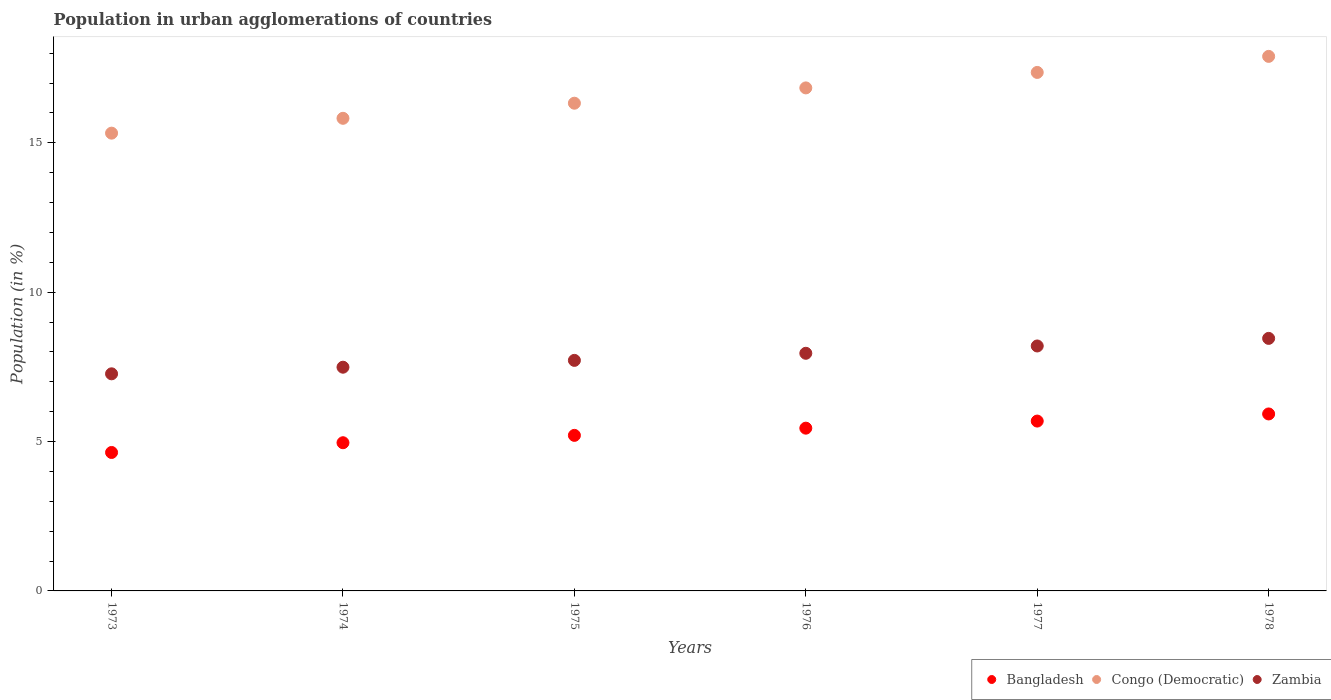How many different coloured dotlines are there?
Your response must be concise. 3. Is the number of dotlines equal to the number of legend labels?
Keep it short and to the point. Yes. What is the percentage of population in urban agglomerations in Bangladesh in 1974?
Provide a short and direct response. 4.96. Across all years, what is the maximum percentage of population in urban agglomerations in Bangladesh?
Provide a short and direct response. 5.92. Across all years, what is the minimum percentage of population in urban agglomerations in Congo (Democratic)?
Your answer should be compact. 15.32. In which year was the percentage of population in urban agglomerations in Bangladesh maximum?
Provide a short and direct response. 1978. What is the total percentage of population in urban agglomerations in Congo (Democratic) in the graph?
Keep it short and to the point. 99.55. What is the difference between the percentage of population in urban agglomerations in Zambia in 1974 and that in 1976?
Make the answer very short. -0.47. What is the difference between the percentage of population in urban agglomerations in Bangladesh in 1978 and the percentage of population in urban agglomerations in Zambia in 1977?
Ensure brevity in your answer.  -2.28. What is the average percentage of population in urban agglomerations in Congo (Democratic) per year?
Your response must be concise. 16.59. In the year 1978, what is the difference between the percentage of population in urban agglomerations in Bangladesh and percentage of population in urban agglomerations in Zambia?
Keep it short and to the point. -2.53. What is the ratio of the percentage of population in urban agglomerations in Zambia in 1975 to that in 1976?
Your answer should be compact. 0.97. Is the difference between the percentage of population in urban agglomerations in Bangladesh in 1974 and 1976 greater than the difference between the percentage of population in urban agglomerations in Zambia in 1974 and 1976?
Provide a succinct answer. No. What is the difference between the highest and the second highest percentage of population in urban agglomerations in Bangladesh?
Give a very brief answer. 0.24. What is the difference between the highest and the lowest percentage of population in urban agglomerations in Bangladesh?
Give a very brief answer. 1.29. Does the percentage of population in urban agglomerations in Bangladesh monotonically increase over the years?
Give a very brief answer. Yes. Is the percentage of population in urban agglomerations in Zambia strictly less than the percentage of population in urban agglomerations in Bangladesh over the years?
Your answer should be very brief. No. How many dotlines are there?
Offer a very short reply. 3. What is the difference between two consecutive major ticks on the Y-axis?
Give a very brief answer. 5. Are the values on the major ticks of Y-axis written in scientific E-notation?
Ensure brevity in your answer.  No. What is the title of the graph?
Make the answer very short. Population in urban agglomerations of countries. Does "China" appear as one of the legend labels in the graph?
Give a very brief answer. No. What is the label or title of the X-axis?
Provide a short and direct response. Years. What is the label or title of the Y-axis?
Offer a terse response. Population (in %). What is the Population (in %) in Bangladesh in 1973?
Your answer should be very brief. 4.63. What is the Population (in %) of Congo (Democratic) in 1973?
Offer a very short reply. 15.32. What is the Population (in %) in Zambia in 1973?
Offer a terse response. 7.27. What is the Population (in %) of Bangladesh in 1974?
Keep it short and to the point. 4.96. What is the Population (in %) in Congo (Democratic) in 1974?
Your answer should be very brief. 15.82. What is the Population (in %) in Zambia in 1974?
Offer a very short reply. 7.49. What is the Population (in %) in Bangladesh in 1975?
Your answer should be very brief. 5.21. What is the Population (in %) in Congo (Democratic) in 1975?
Your answer should be very brief. 16.33. What is the Population (in %) in Zambia in 1975?
Make the answer very short. 7.72. What is the Population (in %) in Bangladesh in 1976?
Keep it short and to the point. 5.45. What is the Population (in %) of Congo (Democratic) in 1976?
Make the answer very short. 16.84. What is the Population (in %) of Zambia in 1976?
Offer a terse response. 7.95. What is the Population (in %) in Bangladesh in 1977?
Your answer should be compact. 5.69. What is the Population (in %) of Congo (Democratic) in 1977?
Keep it short and to the point. 17.36. What is the Population (in %) of Zambia in 1977?
Your answer should be very brief. 8.2. What is the Population (in %) of Bangladesh in 1978?
Your answer should be very brief. 5.92. What is the Population (in %) of Congo (Democratic) in 1978?
Offer a very short reply. 17.89. What is the Population (in %) of Zambia in 1978?
Your answer should be compact. 8.45. Across all years, what is the maximum Population (in %) of Bangladesh?
Your answer should be compact. 5.92. Across all years, what is the maximum Population (in %) in Congo (Democratic)?
Offer a very short reply. 17.89. Across all years, what is the maximum Population (in %) in Zambia?
Offer a terse response. 8.45. Across all years, what is the minimum Population (in %) of Bangladesh?
Your response must be concise. 4.63. Across all years, what is the minimum Population (in %) in Congo (Democratic)?
Offer a terse response. 15.32. Across all years, what is the minimum Population (in %) of Zambia?
Your response must be concise. 7.27. What is the total Population (in %) in Bangladesh in the graph?
Your answer should be very brief. 31.86. What is the total Population (in %) of Congo (Democratic) in the graph?
Your response must be concise. 99.55. What is the total Population (in %) of Zambia in the graph?
Make the answer very short. 47.08. What is the difference between the Population (in %) in Bangladesh in 1973 and that in 1974?
Provide a short and direct response. -0.33. What is the difference between the Population (in %) of Congo (Democratic) in 1973 and that in 1974?
Your answer should be very brief. -0.5. What is the difference between the Population (in %) of Zambia in 1973 and that in 1974?
Provide a short and direct response. -0.22. What is the difference between the Population (in %) in Bangladesh in 1973 and that in 1975?
Your answer should be very brief. -0.57. What is the difference between the Population (in %) of Congo (Democratic) in 1973 and that in 1975?
Give a very brief answer. -1. What is the difference between the Population (in %) of Zambia in 1973 and that in 1975?
Your answer should be compact. -0.45. What is the difference between the Population (in %) of Bangladesh in 1973 and that in 1976?
Offer a terse response. -0.81. What is the difference between the Population (in %) in Congo (Democratic) in 1973 and that in 1976?
Keep it short and to the point. -1.51. What is the difference between the Population (in %) in Zambia in 1973 and that in 1976?
Your answer should be very brief. -0.69. What is the difference between the Population (in %) in Bangladesh in 1973 and that in 1977?
Provide a succinct answer. -1.05. What is the difference between the Population (in %) in Congo (Democratic) in 1973 and that in 1977?
Provide a short and direct response. -2.03. What is the difference between the Population (in %) of Zambia in 1973 and that in 1977?
Offer a very short reply. -0.93. What is the difference between the Population (in %) of Bangladesh in 1973 and that in 1978?
Your response must be concise. -1.29. What is the difference between the Population (in %) of Congo (Democratic) in 1973 and that in 1978?
Your response must be concise. -2.57. What is the difference between the Population (in %) in Zambia in 1973 and that in 1978?
Provide a succinct answer. -1.19. What is the difference between the Population (in %) in Bangladesh in 1974 and that in 1975?
Offer a terse response. -0.25. What is the difference between the Population (in %) of Congo (Democratic) in 1974 and that in 1975?
Your response must be concise. -0.51. What is the difference between the Population (in %) in Zambia in 1974 and that in 1975?
Give a very brief answer. -0.23. What is the difference between the Population (in %) of Bangladesh in 1974 and that in 1976?
Your answer should be compact. -0.49. What is the difference between the Population (in %) of Congo (Democratic) in 1974 and that in 1976?
Offer a terse response. -1.02. What is the difference between the Population (in %) in Zambia in 1974 and that in 1976?
Offer a very short reply. -0.47. What is the difference between the Population (in %) in Bangladesh in 1974 and that in 1977?
Ensure brevity in your answer.  -0.72. What is the difference between the Population (in %) of Congo (Democratic) in 1974 and that in 1977?
Ensure brevity in your answer.  -1.54. What is the difference between the Population (in %) of Zambia in 1974 and that in 1977?
Make the answer very short. -0.71. What is the difference between the Population (in %) in Bangladesh in 1974 and that in 1978?
Your answer should be compact. -0.96. What is the difference between the Population (in %) of Congo (Democratic) in 1974 and that in 1978?
Provide a succinct answer. -2.07. What is the difference between the Population (in %) of Zambia in 1974 and that in 1978?
Provide a succinct answer. -0.96. What is the difference between the Population (in %) of Bangladesh in 1975 and that in 1976?
Provide a succinct answer. -0.24. What is the difference between the Population (in %) in Congo (Democratic) in 1975 and that in 1976?
Make the answer very short. -0.51. What is the difference between the Population (in %) of Zambia in 1975 and that in 1976?
Offer a very short reply. -0.24. What is the difference between the Population (in %) of Bangladesh in 1975 and that in 1977?
Keep it short and to the point. -0.48. What is the difference between the Population (in %) of Congo (Democratic) in 1975 and that in 1977?
Your answer should be very brief. -1.03. What is the difference between the Population (in %) of Zambia in 1975 and that in 1977?
Your response must be concise. -0.48. What is the difference between the Population (in %) in Bangladesh in 1975 and that in 1978?
Your answer should be very brief. -0.72. What is the difference between the Population (in %) in Congo (Democratic) in 1975 and that in 1978?
Make the answer very short. -1.57. What is the difference between the Population (in %) in Zambia in 1975 and that in 1978?
Your answer should be very brief. -0.74. What is the difference between the Population (in %) in Bangladesh in 1976 and that in 1977?
Ensure brevity in your answer.  -0.24. What is the difference between the Population (in %) of Congo (Democratic) in 1976 and that in 1977?
Provide a short and direct response. -0.52. What is the difference between the Population (in %) in Zambia in 1976 and that in 1977?
Provide a succinct answer. -0.24. What is the difference between the Population (in %) of Bangladesh in 1976 and that in 1978?
Make the answer very short. -0.48. What is the difference between the Population (in %) of Congo (Democratic) in 1976 and that in 1978?
Provide a short and direct response. -1.06. What is the difference between the Population (in %) in Zambia in 1976 and that in 1978?
Provide a succinct answer. -0.5. What is the difference between the Population (in %) of Bangladesh in 1977 and that in 1978?
Offer a very short reply. -0.24. What is the difference between the Population (in %) of Congo (Democratic) in 1977 and that in 1978?
Your answer should be compact. -0.54. What is the difference between the Population (in %) in Zambia in 1977 and that in 1978?
Keep it short and to the point. -0.25. What is the difference between the Population (in %) in Bangladesh in 1973 and the Population (in %) in Congo (Democratic) in 1974?
Offer a very short reply. -11.19. What is the difference between the Population (in %) in Bangladesh in 1973 and the Population (in %) in Zambia in 1974?
Your response must be concise. -2.85. What is the difference between the Population (in %) of Congo (Democratic) in 1973 and the Population (in %) of Zambia in 1974?
Offer a terse response. 7.83. What is the difference between the Population (in %) of Bangladesh in 1973 and the Population (in %) of Congo (Democratic) in 1975?
Offer a very short reply. -11.69. What is the difference between the Population (in %) in Bangladesh in 1973 and the Population (in %) in Zambia in 1975?
Your response must be concise. -3.08. What is the difference between the Population (in %) of Congo (Democratic) in 1973 and the Population (in %) of Zambia in 1975?
Provide a succinct answer. 7.61. What is the difference between the Population (in %) of Bangladesh in 1973 and the Population (in %) of Congo (Democratic) in 1976?
Make the answer very short. -12.2. What is the difference between the Population (in %) in Bangladesh in 1973 and the Population (in %) in Zambia in 1976?
Offer a terse response. -3.32. What is the difference between the Population (in %) in Congo (Democratic) in 1973 and the Population (in %) in Zambia in 1976?
Your answer should be very brief. 7.37. What is the difference between the Population (in %) of Bangladesh in 1973 and the Population (in %) of Congo (Democratic) in 1977?
Provide a succinct answer. -12.72. What is the difference between the Population (in %) of Bangladesh in 1973 and the Population (in %) of Zambia in 1977?
Make the answer very short. -3.56. What is the difference between the Population (in %) of Congo (Democratic) in 1973 and the Population (in %) of Zambia in 1977?
Ensure brevity in your answer.  7.12. What is the difference between the Population (in %) in Bangladesh in 1973 and the Population (in %) in Congo (Democratic) in 1978?
Your response must be concise. -13.26. What is the difference between the Population (in %) in Bangladesh in 1973 and the Population (in %) in Zambia in 1978?
Give a very brief answer. -3.82. What is the difference between the Population (in %) of Congo (Democratic) in 1973 and the Population (in %) of Zambia in 1978?
Provide a short and direct response. 6.87. What is the difference between the Population (in %) of Bangladesh in 1974 and the Population (in %) of Congo (Democratic) in 1975?
Ensure brevity in your answer.  -11.37. What is the difference between the Population (in %) of Bangladesh in 1974 and the Population (in %) of Zambia in 1975?
Offer a terse response. -2.76. What is the difference between the Population (in %) of Congo (Democratic) in 1974 and the Population (in %) of Zambia in 1975?
Keep it short and to the point. 8.1. What is the difference between the Population (in %) in Bangladesh in 1974 and the Population (in %) in Congo (Democratic) in 1976?
Ensure brevity in your answer.  -11.88. What is the difference between the Population (in %) in Bangladesh in 1974 and the Population (in %) in Zambia in 1976?
Offer a very short reply. -2.99. What is the difference between the Population (in %) in Congo (Democratic) in 1974 and the Population (in %) in Zambia in 1976?
Keep it short and to the point. 7.87. What is the difference between the Population (in %) of Bangladesh in 1974 and the Population (in %) of Congo (Democratic) in 1977?
Offer a terse response. -12.4. What is the difference between the Population (in %) of Bangladesh in 1974 and the Population (in %) of Zambia in 1977?
Offer a terse response. -3.24. What is the difference between the Population (in %) in Congo (Democratic) in 1974 and the Population (in %) in Zambia in 1977?
Make the answer very short. 7.62. What is the difference between the Population (in %) in Bangladesh in 1974 and the Population (in %) in Congo (Democratic) in 1978?
Ensure brevity in your answer.  -12.93. What is the difference between the Population (in %) in Bangladesh in 1974 and the Population (in %) in Zambia in 1978?
Provide a short and direct response. -3.49. What is the difference between the Population (in %) of Congo (Democratic) in 1974 and the Population (in %) of Zambia in 1978?
Your response must be concise. 7.37. What is the difference between the Population (in %) in Bangladesh in 1975 and the Population (in %) in Congo (Democratic) in 1976?
Provide a short and direct response. -11.63. What is the difference between the Population (in %) in Bangladesh in 1975 and the Population (in %) in Zambia in 1976?
Keep it short and to the point. -2.75. What is the difference between the Population (in %) in Congo (Democratic) in 1975 and the Population (in %) in Zambia in 1976?
Ensure brevity in your answer.  8.37. What is the difference between the Population (in %) of Bangladesh in 1975 and the Population (in %) of Congo (Democratic) in 1977?
Keep it short and to the point. -12.15. What is the difference between the Population (in %) of Bangladesh in 1975 and the Population (in %) of Zambia in 1977?
Keep it short and to the point. -2.99. What is the difference between the Population (in %) in Congo (Democratic) in 1975 and the Population (in %) in Zambia in 1977?
Offer a very short reply. 8.13. What is the difference between the Population (in %) of Bangladesh in 1975 and the Population (in %) of Congo (Democratic) in 1978?
Make the answer very short. -12.69. What is the difference between the Population (in %) of Bangladesh in 1975 and the Population (in %) of Zambia in 1978?
Provide a short and direct response. -3.25. What is the difference between the Population (in %) of Congo (Democratic) in 1975 and the Population (in %) of Zambia in 1978?
Your response must be concise. 7.87. What is the difference between the Population (in %) of Bangladesh in 1976 and the Population (in %) of Congo (Democratic) in 1977?
Your response must be concise. -11.91. What is the difference between the Population (in %) in Bangladesh in 1976 and the Population (in %) in Zambia in 1977?
Offer a very short reply. -2.75. What is the difference between the Population (in %) of Congo (Democratic) in 1976 and the Population (in %) of Zambia in 1977?
Offer a terse response. 8.64. What is the difference between the Population (in %) in Bangladesh in 1976 and the Population (in %) in Congo (Democratic) in 1978?
Keep it short and to the point. -12.44. What is the difference between the Population (in %) in Bangladesh in 1976 and the Population (in %) in Zambia in 1978?
Offer a terse response. -3. What is the difference between the Population (in %) of Congo (Democratic) in 1976 and the Population (in %) of Zambia in 1978?
Offer a very short reply. 8.38. What is the difference between the Population (in %) in Bangladesh in 1977 and the Population (in %) in Congo (Democratic) in 1978?
Keep it short and to the point. -12.21. What is the difference between the Population (in %) of Bangladesh in 1977 and the Population (in %) of Zambia in 1978?
Provide a short and direct response. -2.77. What is the difference between the Population (in %) in Congo (Democratic) in 1977 and the Population (in %) in Zambia in 1978?
Provide a short and direct response. 8.9. What is the average Population (in %) of Bangladesh per year?
Provide a short and direct response. 5.31. What is the average Population (in %) of Congo (Democratic) per year?
Offer a terse response. 16.59. What is the average Population (in %) in Zambia per year?
Your answer should be compact. 7.85. In the year 1973, what is the difference between the Population (in %) of Bangladesh and Population (in %) of Congo (Democratic)?
Provide a succinct answer. -10.69. In the year 1973, what is the difference between the Population (in %) of Bangladesh and Population (in %) of Zambia?
Offer a very short reply. -2.63. In the year 1973, what is the difference between the Population (in %) in Congo (Democratic) and Population (in %) in Zambia?
Ensure brevity in your answer.  8.06. In the year 1974, what is the difference between the Population (in %) of Bangladesh and Population (in %) of Congo (Democratic)?
Offer a very short reply. -10.86. In the year 1974, what is the difference between the Population (in %) in Bangladesh and Population (in %) in Zambia?
Ensure brevity in your answer.  -2.53. In the year 1974, what is the difference between the Population (in %) in Congo (Democratic) and Population (in %) in Zambia?
Offer a terse response. 8.33. In the year 1975, what is the difference between the Population (in %) of Bangladesh and Population (in %) of Congo (Democratic)?
Provide a succinct answer. -11.12. In the year 1975, what is the difference between the Population (in %) in Bangladesh and Population (in %) in Zambia?
Your answer should be very brief. -2.51. In the year 1975, what is the difference between the Population (in %) in Congo (Democratic) and Population (in %) in Zambia?
Provide a succinct answer. 8.61. In the year 1976, what is the difference between the Population (in %) of Bangladesh and Population (in %) of Congo (Democratic)?
Your answer should be compact. -11.39. In the year 1976, what is the difference between the Population (in %) in Bangladesh and Population (in %) in Zambia?
Ensure brevity in your answer.  -2.51. In the year 1976, what is the difference between the Population (in %) of Congo (Democratic) and Population (in %) of Zambia?
Your answer should be very brief. 8.88. In the year 1977, what is the difference between the Population (in %) of Bangladesh and Population (in %) of Congo (Democratic)?
Provide a succinct answer. -11.67. In the year 1977, what is the difference between the Population (in %) of Bangladesh and Population (in %) of Zambia?
Your response must be concise. -2.51. In the year 1977, what is the difference between the Population (in %) of Congo (Democratic) and Population (in %) of Zambia?
Give a very brief answer. 9.16. In the year 1978, what is the difference between the Population (in %) in Bangladesh and Population (in %) in Congo (Democratic)?
Give a very brief answer. -11.97. In the year 1978, what is the difference between the Population (in %) of Bangladesh and Population (in %) of Zambia?
Keep it short and to the point. -2.53. In the year 1978, what is the difference between the Population (in %) in Congo (Democratic) and Population (in %) in Zambia?
Make the answer very short. 9.44. What is the ratio of the Population (in %) in Bangladesh in 1973 to that in 1974?
Offer a terse response. 0.93. What is the ratio of the Population (in %) of Congo (Democratic) in 1973 to that in 1974?
Provide a short and direct response. 0.97. What is the ratio of the Population (in %) of Zambia in 1973 to that in 1974?
Ensure brevity in your answer.  0.97. What is the ratio of the Population (in %) of Bangladesh in 1973 to that in 1975?
Your answer should be compact. 0.89. What is the ratio of the Population (in %) in Congo (Democratic) in 1973 to that in 1975?
Provide a succinct answer. 0.94. What is the ratio of the Population (in %) in Zambia in 1973 to that in 1975?
Provide a succinct answer. 0.94. What is the ratio of the Population (in %) in Bangladesh in 1973 to that in 1976?
Your answer should be compact. 0.85. What is the ratio of the Population (in %) in Congo (Democratic) in 1973 to that in 1976?
Make the answer very short. 0.91. What is the ratio of the Population (in %) in Zambia in 1973 to that in 1976?
Your answer should be compact. 0.91. What is the ratio of the Population (in %) of Bangladesh in 1973 to that in 1977?
Offer a very short reply. 0.82. What is the ratio of the Population (in %) of Congo (Democratic) in 1973 to that in 1977?
Ensure brevity in your answer.  0.88. What is the ratio of the Population (in %) of Zambia in 1973 to that in 1977?
Provide a succinct answer. 0.89. What is the ratio of the Population (in %) in Bangladesh in 1973 to that in 1978?
Offer a terse response. 0.78. What is the ratio of the Population (in %) of Congo (Democratic) in 1973 to that in 1978?
Provide a short and direct response. 0.86. What is the ratio of the Population (in %) of Zambia in 1973 to that in 1978?
Give a very brief answer. 0.86. What is the ratio of the Population (in %) in Bangladesh in 1974 to that in 1975?
Ensure brevity in your answer.  0.95. What is the ratio of the Population (in %) in Congo (Democratic) in 1974 to that in 1975?
Make the answer very short. 0.97. What is the ratio of the Population (in %) of Zambia in 1974 to that in 1975?
Provide a succinct answer. 0.97. What is the ratio of the Population (in %) in Bangladesh in 1974 to that in 1976?
Your response must be concise. 0.91. What is the ratio of the Population (in %) of Congo (Democratic) in 1974 to that in 1976?
Your answer should be compact. 0.94. What is the ratio of the Population (in %) of Zambia in 1974 to that in 1976?
Provide a succinct answer. 0.94. What is the ratio of the Population (in %) in Bangladesh in 1974 to that in 1977?
Offer a very short reply. 0.87. What is the ratio of the Population (in %) of Congo (Democratic) in 1974 to that in 1977?
Ensure brevity in your answer.  0.91. What is the ratio of the Population (in %) in Zambia in 1974 to that in 1977?
Your response must be concise. 0.91. What is the ratio of the Population (in %) of Bangladesh in 1974 to that in 1978?
Offer a terse response. 0.84. What is the ratio of the Population (in %) in Congo (Democratic) in 1974 to that in 1978?
Give a very brief answer. 0.88. What is the ratio of the Population (in %) in Zambia in 1974 to that in 1978?
Give a very brief answer. 0.89. What is the ratio of the Population (in %) in Bangladesh in 1975 to that in 1976?
Your answer should be compact. 0.96. What is the ratio of the Population (in %) in Congo (Democratic) in 1975 to that in 1976?
Offer a very short reply. 0.97. What is the ratio of the Population (in %) of Zambia in 1975 to that in 1976?
Keep it short and to the point. 0.97. What is the ratio of the Population (in %) of Bangladesh in 1975 to that in 1977?
Your answer should be compact. 0.92. What is the ratio of the Population (in %) of Congo (Democratic) in 1975 to that in 1977?
Give a very brief answer. 0.94. What is the ratio of the Population (in %) of Bangladesh in 1975 to that in 1978?
Make the answer very short. 0.88. What is the ratio of the Population (in %) of Congo (Democratic) in 1975 to that in 1978?
Offer a very short reply. 0.91. What is the ratio of the Population (in %) of Zambia in 1975 to that in 1978?
Your answer should be very brief. 0.91. What is the ratio of the Population (in %) in Congo (Democratic) in 1976 to that in 1977?
Provide a short and direct response. 0.97. What is the ratio of the Population (in %) of Zambia in 1976 to that in 1977?
Ensure brevity in your answer.  0.97. What is the ratio of the Population (in %) of Bangladesh in 1976 to that in 1978?
Your answer should be very brief. 0.92. What is the ratio of the Population (in %) of Congo (Democratic) in 1976 to that in 1978?
Your response must be concise. 0.94. What is the ratio of the Population (in %) in Zambia in 1976 to that in 1978?
Offer a very short reply. 0.94. What is the ratio of the Population (in %) of Bangladesh in 1977 to that in 1978?
Provide a succinct answer. 0.96. What is the ratio of the Population (in %) in Congo (Democratic) in 1977 to that in 1978?
Keep it short and to the point. 0.97. What is the difference between the highest and the second highest Population (in %) in Bangladesh?
Offer a terse response. 0.24. What is the difference between the highest and the second highest Population (in %) of Congo (Democratic)?
Offer a very short reply. 0.54. What is the difference between the highest and the second highest Population (in %) in Zambia?
Offer a very short reply. 0.25. What is the difference between the highest and the lowest Population (in %) of Bangladesh?
Your response must be concise. 1.29. What is the difference between the highest and the lowest Population (in %) of Congo (Democratic)?
Keep it short and to the point. 2.57. What is the difference between the highest and the lowest Population (in %) in Zambia?
Keep it short and to the point. 1.19. 